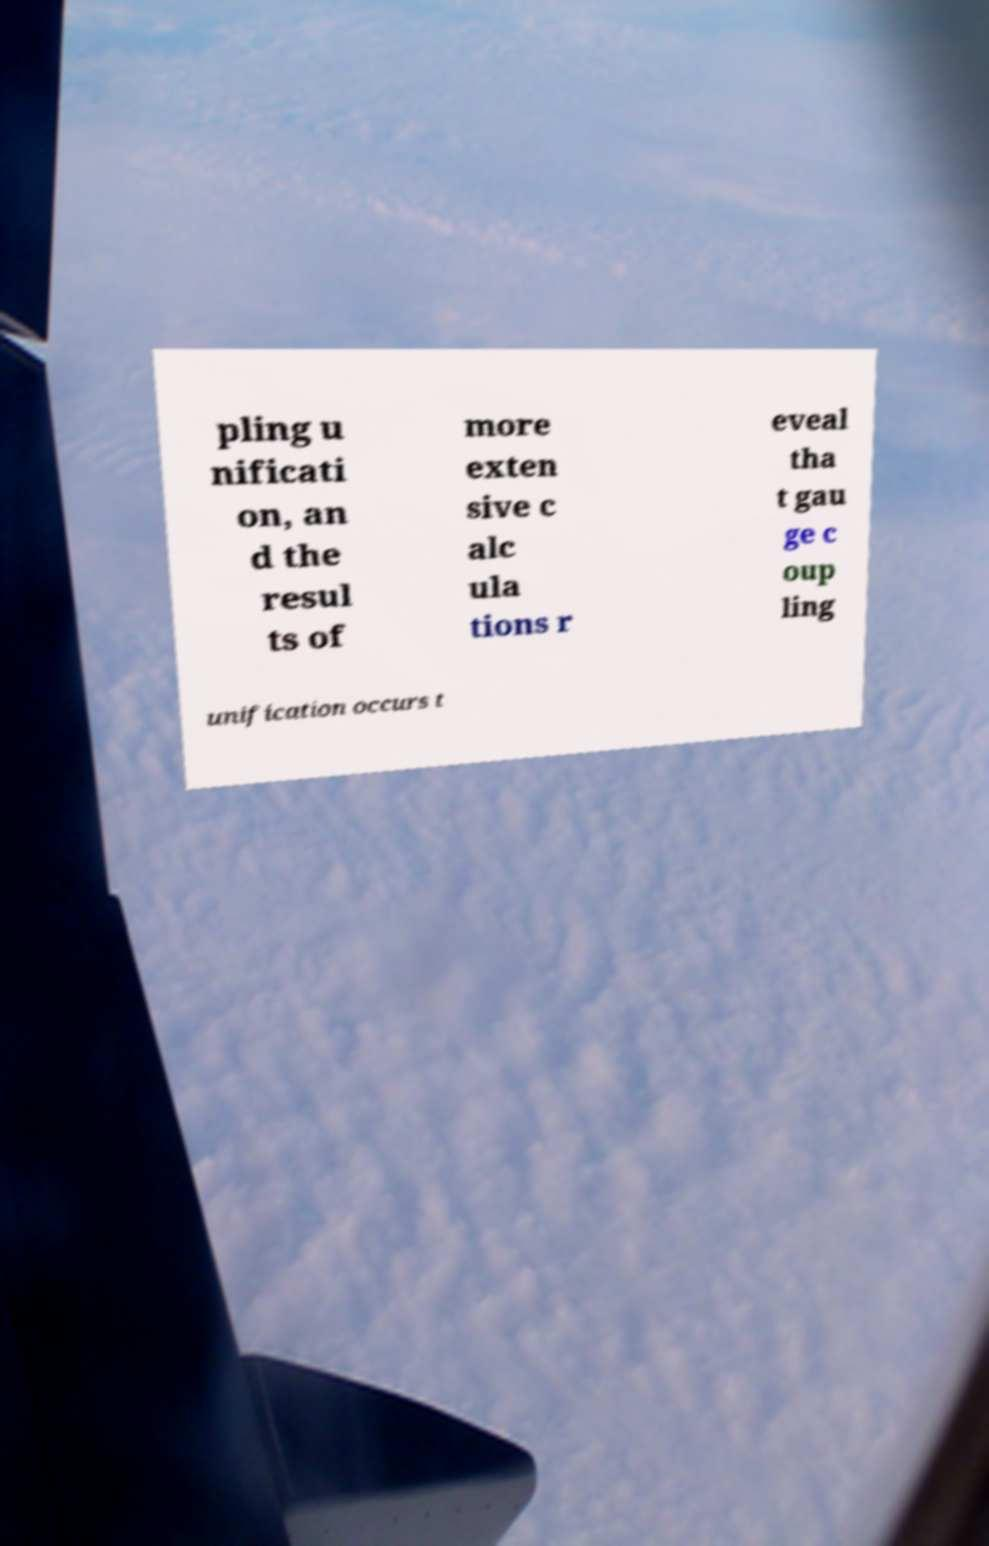Could you assist in decoding the text presented in this image and type it out clearly? pling u nificati on, an d the resul ts of more exten sive c alc ula tions r eveal tha t gau ge c oup ling unification occurs t 